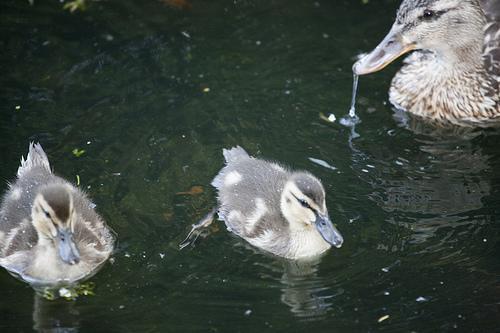How many ducks?
Give a very brief answer. 3. 